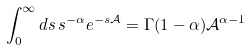<formula> <loc_0><loc_0><loc_500><loc_500>\int _ { 0 } ^ { \infty } d s \, s ^ { - \alpha } e ^ { - s \mathcal { A } } = \Gamma ( 1 - \alpha ) \mathcal { A } ^ { \alpha - 1 }</formula> 